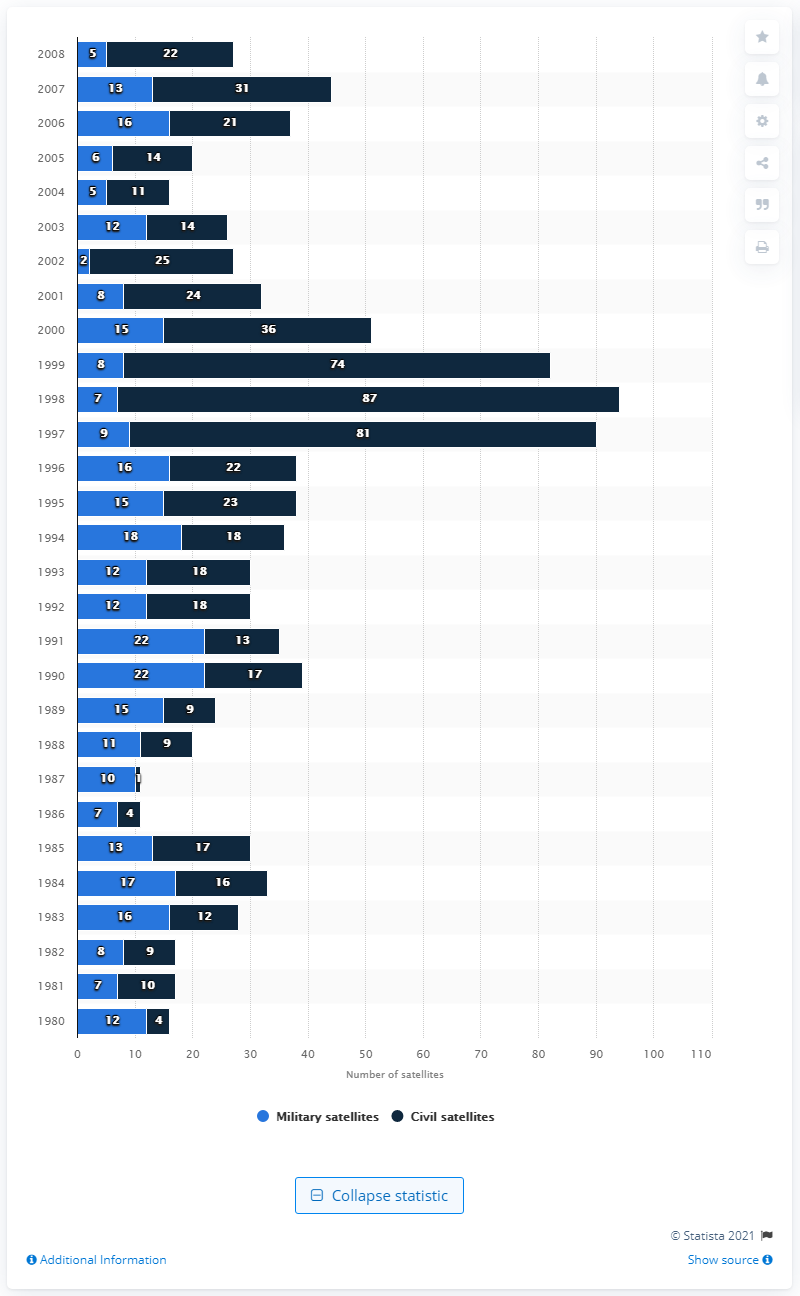Outline some significant characteristics in this image. In 2008, five military satellites were successfully launched. In 2008, a total of 22 civil satellites were launched. 